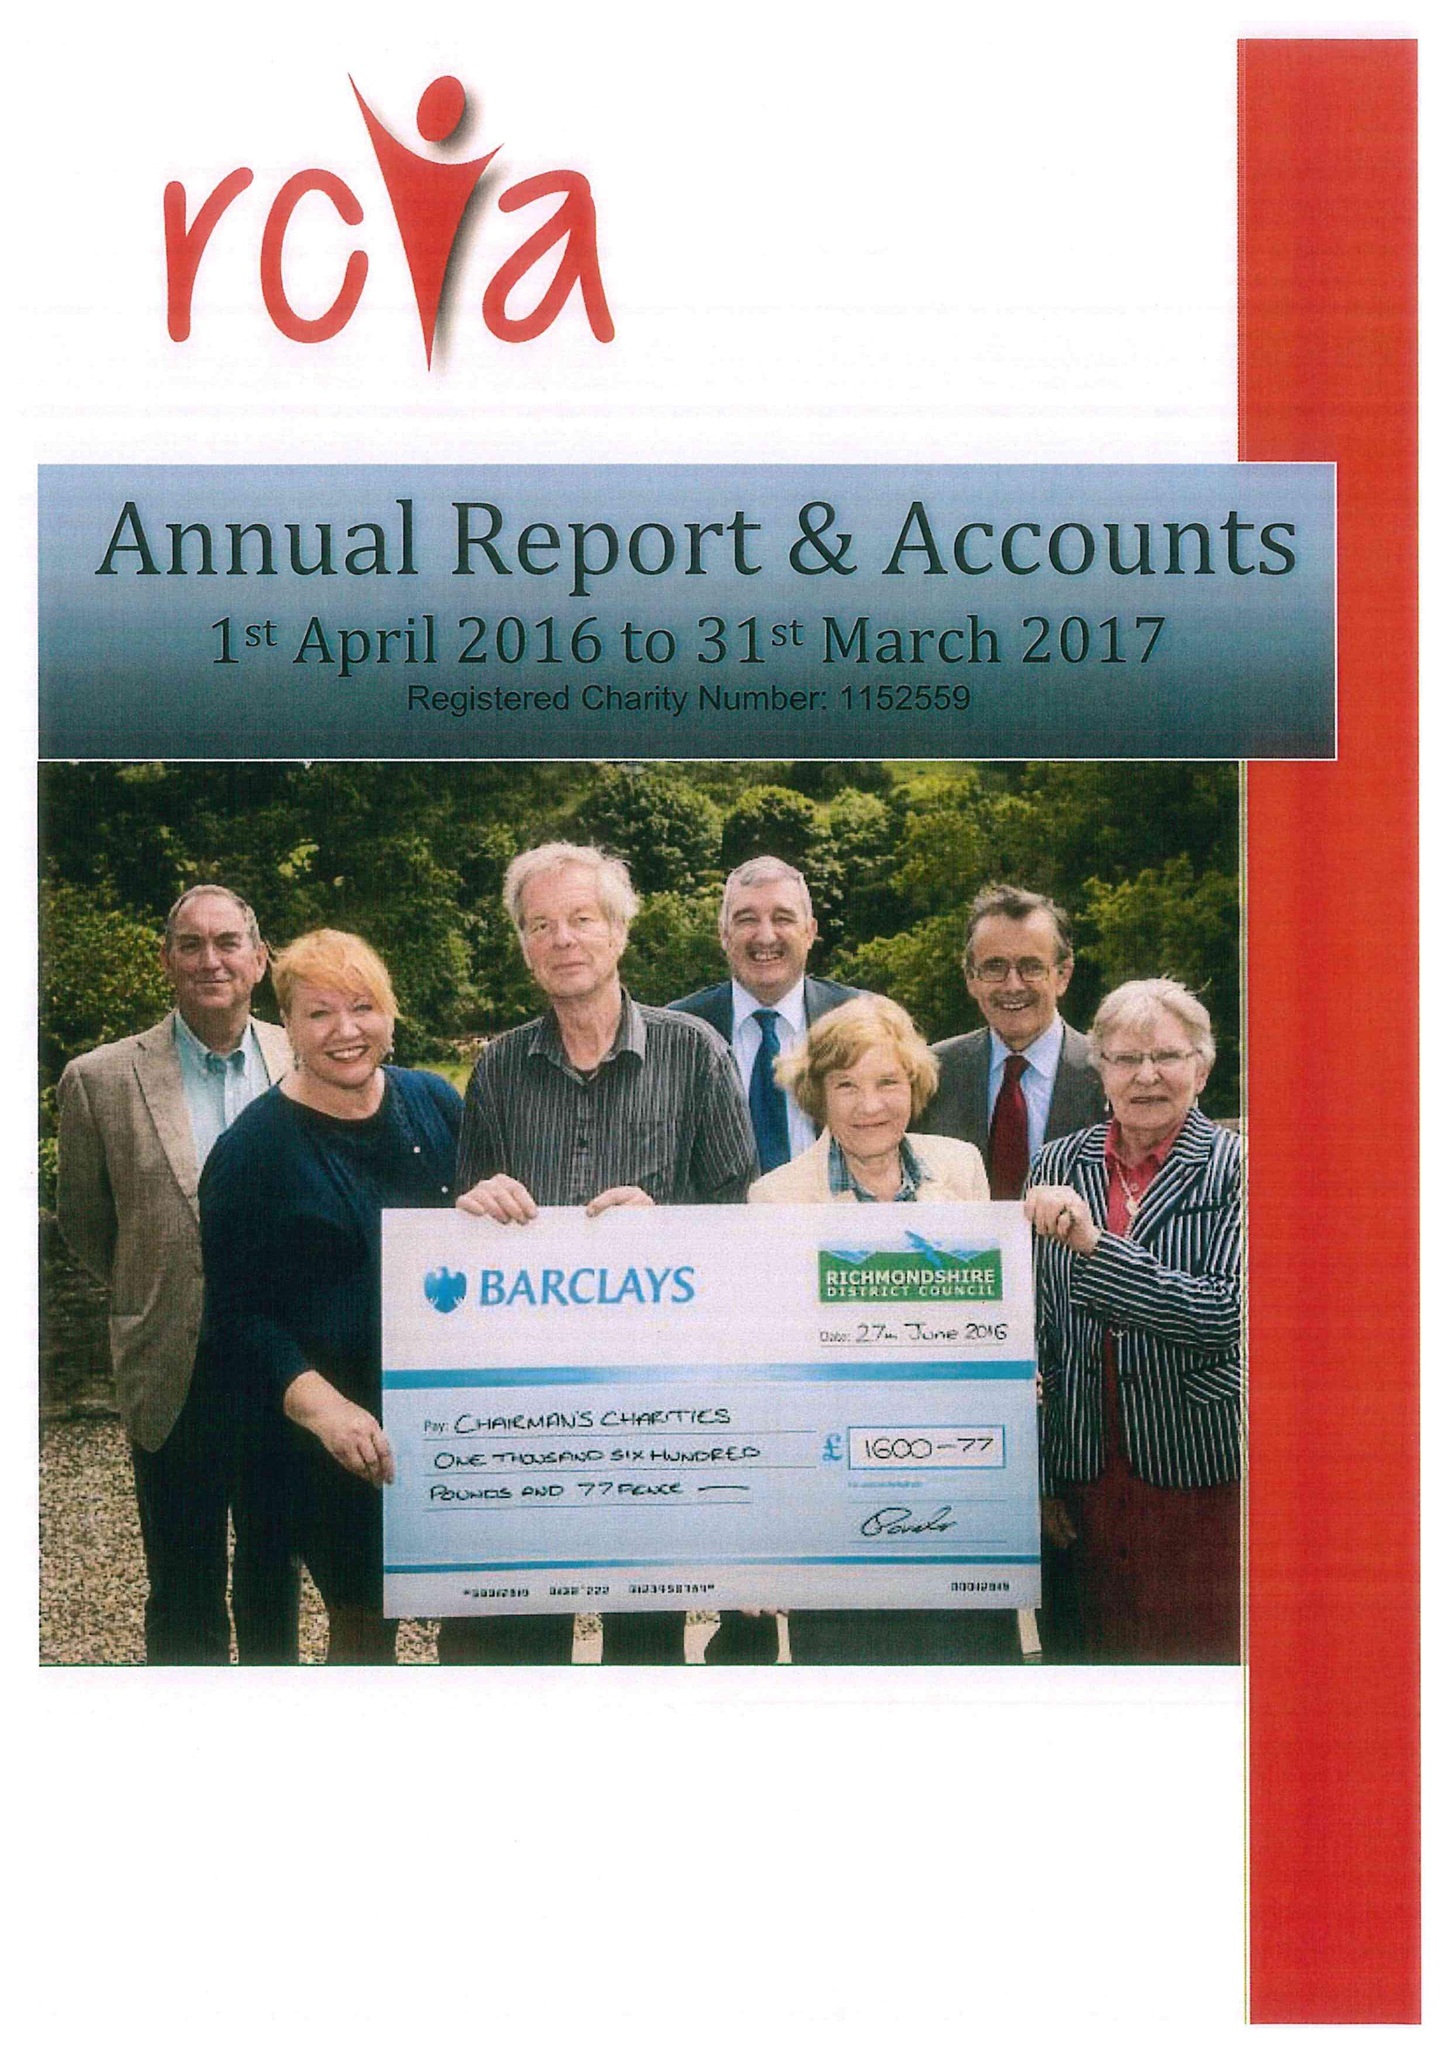What is the value for the spending_annually_in_british_pounds?
Answer the question using a single word or phrase. 152814.00 